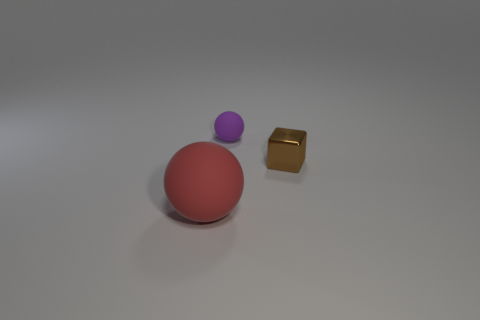Are there any other things that have the same material as the tiny brown cube?
Provide a succinct answer. No. Does the purple thing have the same material as the thing that is to the right of the small purple thing?
Offer a very short reply. No. Are any big blue matte cubes visible?
Give a very brief answer. No. There is a sphere that is the same material as the big red thing; what size is it?
Make the answer very short. Small. The rubber object behind the sphere on the left side of the matte object that is right of the large red rubber ball is what shape?
Give a very brief answer. Sphere. Are there the same number of brown objects behind the small metal object and big cylinders?
Provide a succinct answer. Yes. Is the metal thing the same shape as the small purple matte thing?
Your answer should be very brief. No. What number of things are rubber objects behind the brown metal cube or tiny blue matte things?
Provide a short and direct response. 1. Are there the same number of big balls right of the tiny purple matte sphere and rubber spheres right of the red object?
Your answer should be compact. No. How many other objects are the same shape as the tiny purple rubber thing?
Provide a short and direct response. 1. 